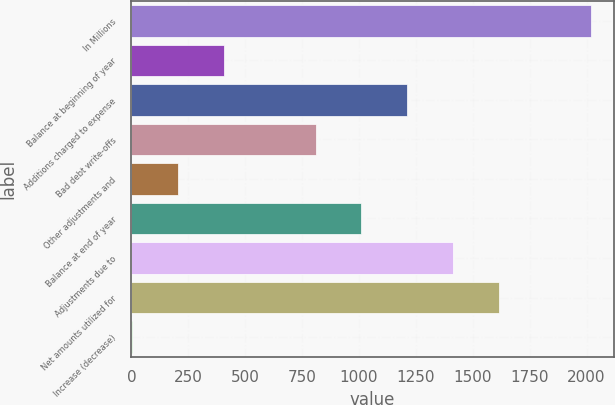Convert chart. <chart><loc_0><loc_0><loc_500><loc_500><bar_chart><fcel>In Millions<fcel>Balance at beginning of year<fcel>Additions charged to expense<fcel>Bad debt write-offs<fcel>Other adjustments and<fcel>Balance at end of year<fcel>Adjustments due to<fcel>Net amounts utilized for<fcel>Increase (decrease)<nl><fcel>2018<fcel>406.88<fcel>1212.44<fcel>809.66<fcel>205.49<fcel>1011.05<fcel>1413.83<fcel>1615.22<fcel>4.1<nl></chart> 